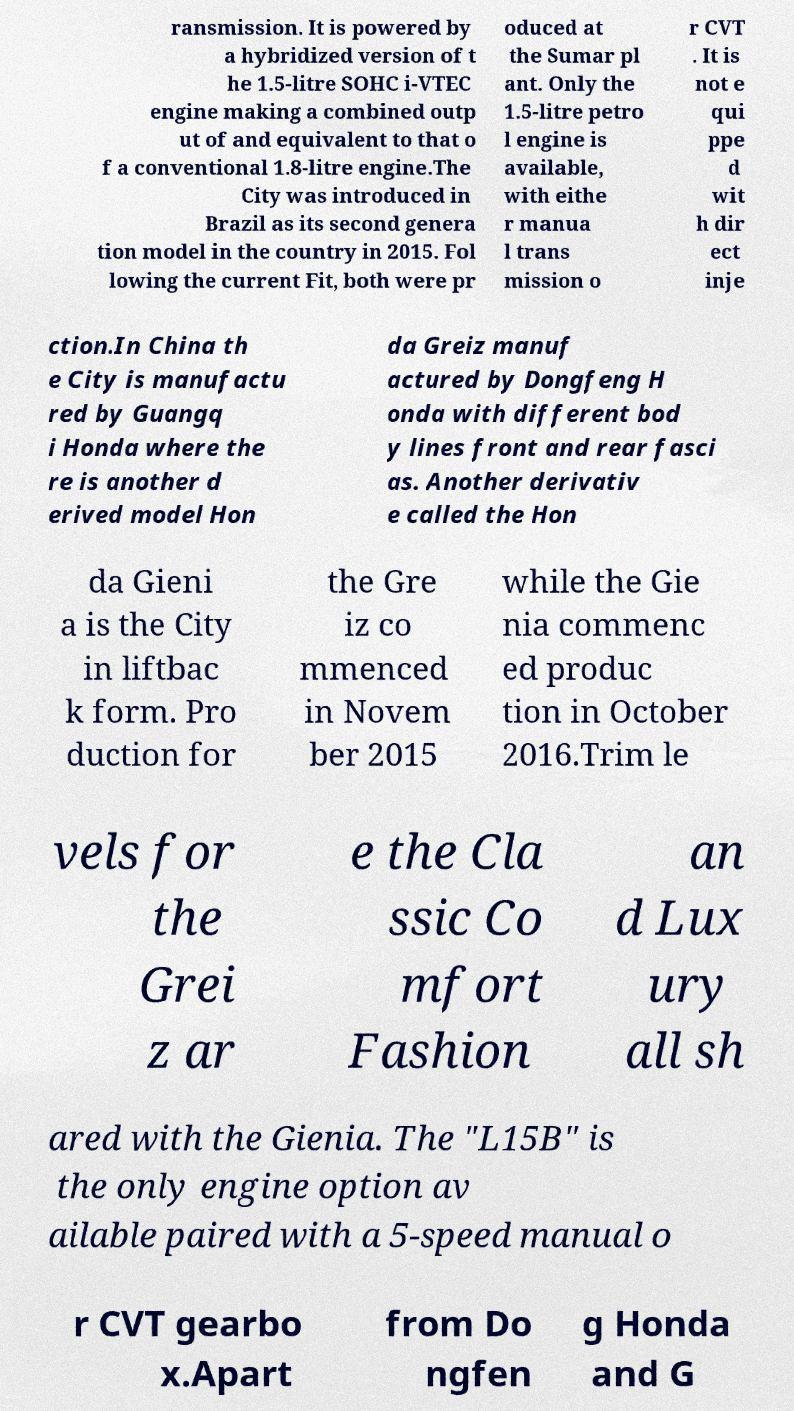For documentation purposes, I need the text within this image transcribed. Could you provide that? ransmission. It is powered by a hybridized version of t he 1.5-litre SOHC i-VTEC engine making a combined outp ut of and equivalent to that o f a conventional 1.8-litre engine.The City was introduced in Brazil as its second genera tion model in the country in 2015. Fol lowing the current Fit, both were pr oduced at the Sumar pl ant. Only the 1.5-litre petro l engine is available, with eithe r manua l trans mission o r CVT . It is not e qui ppe d wit h dir ect inje ction.In China th e City is manufactu red by Guangq i Honda where the re is another d erived model Hon da Greiz manuf actured by Dongfeng H onda with different bod y lines front and rear fasci as. Another derivativ e called the Hon da Gieni a is the City in liftbac k form. Pro duction for the Gre iz co mmenced in Novem ber 2015 while the Gie nia commenc ed produc tion in October 2016.Trim le vels for the Grei z ar e the Cla ssic Co mfort Fashion an d Lux ury all sh ared with the Gienia. The "L15B" is the only engine option av ailable paired with a 5-speed manual o r CVT gearbo x.Apart from Do ngfen g Honda and G 